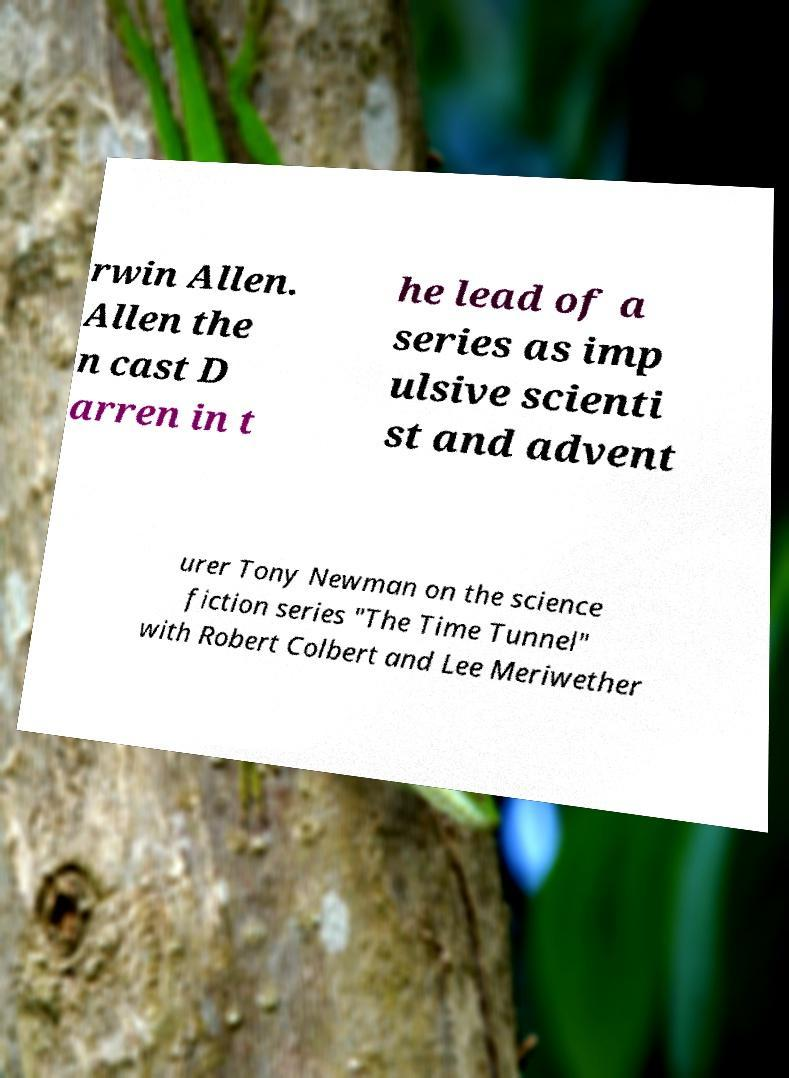Please read and relay the text visible in this image. What does it say? rwin Allen. Allen the n cast D arren in t he lead of a series as imp ulsive scienti st and advent urer Tony Newman on the science fiction series "The Time Tunnel" with Robert Colbert and Lee Meriwether 